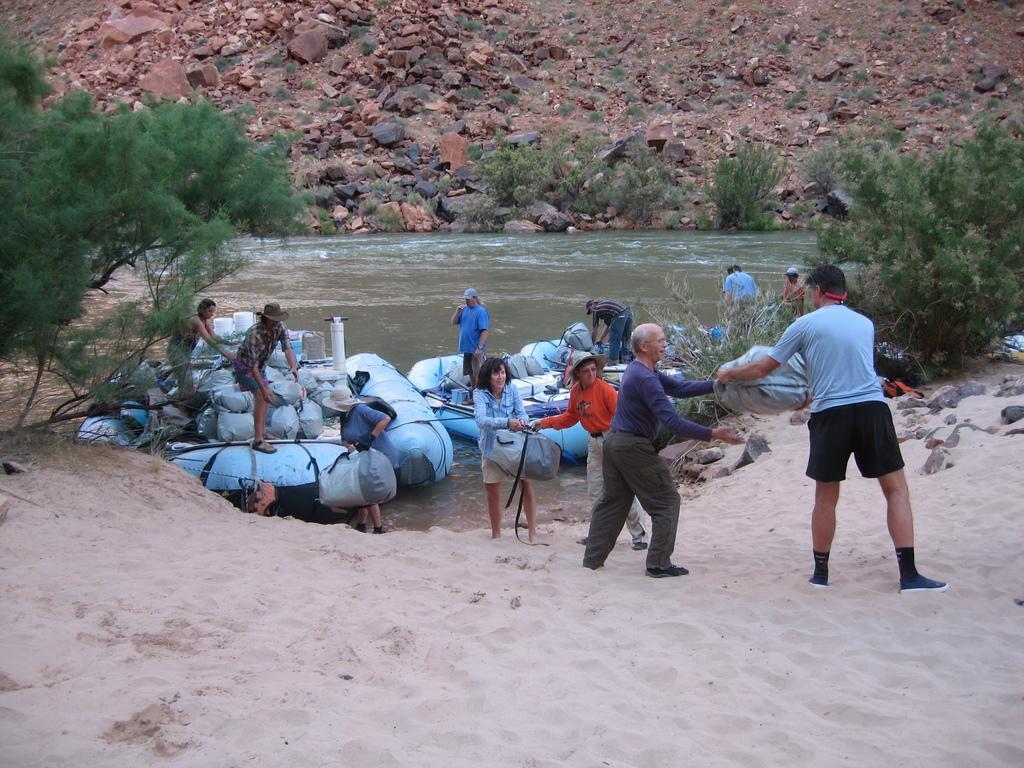Describe this image in one or two sentences. In front of the image there are a few people passing some objects, behind them there are a few people standing on the objects in the water. Around the water, there are trees. In front of the water, there is sand. Behind the water, there are rocks. 